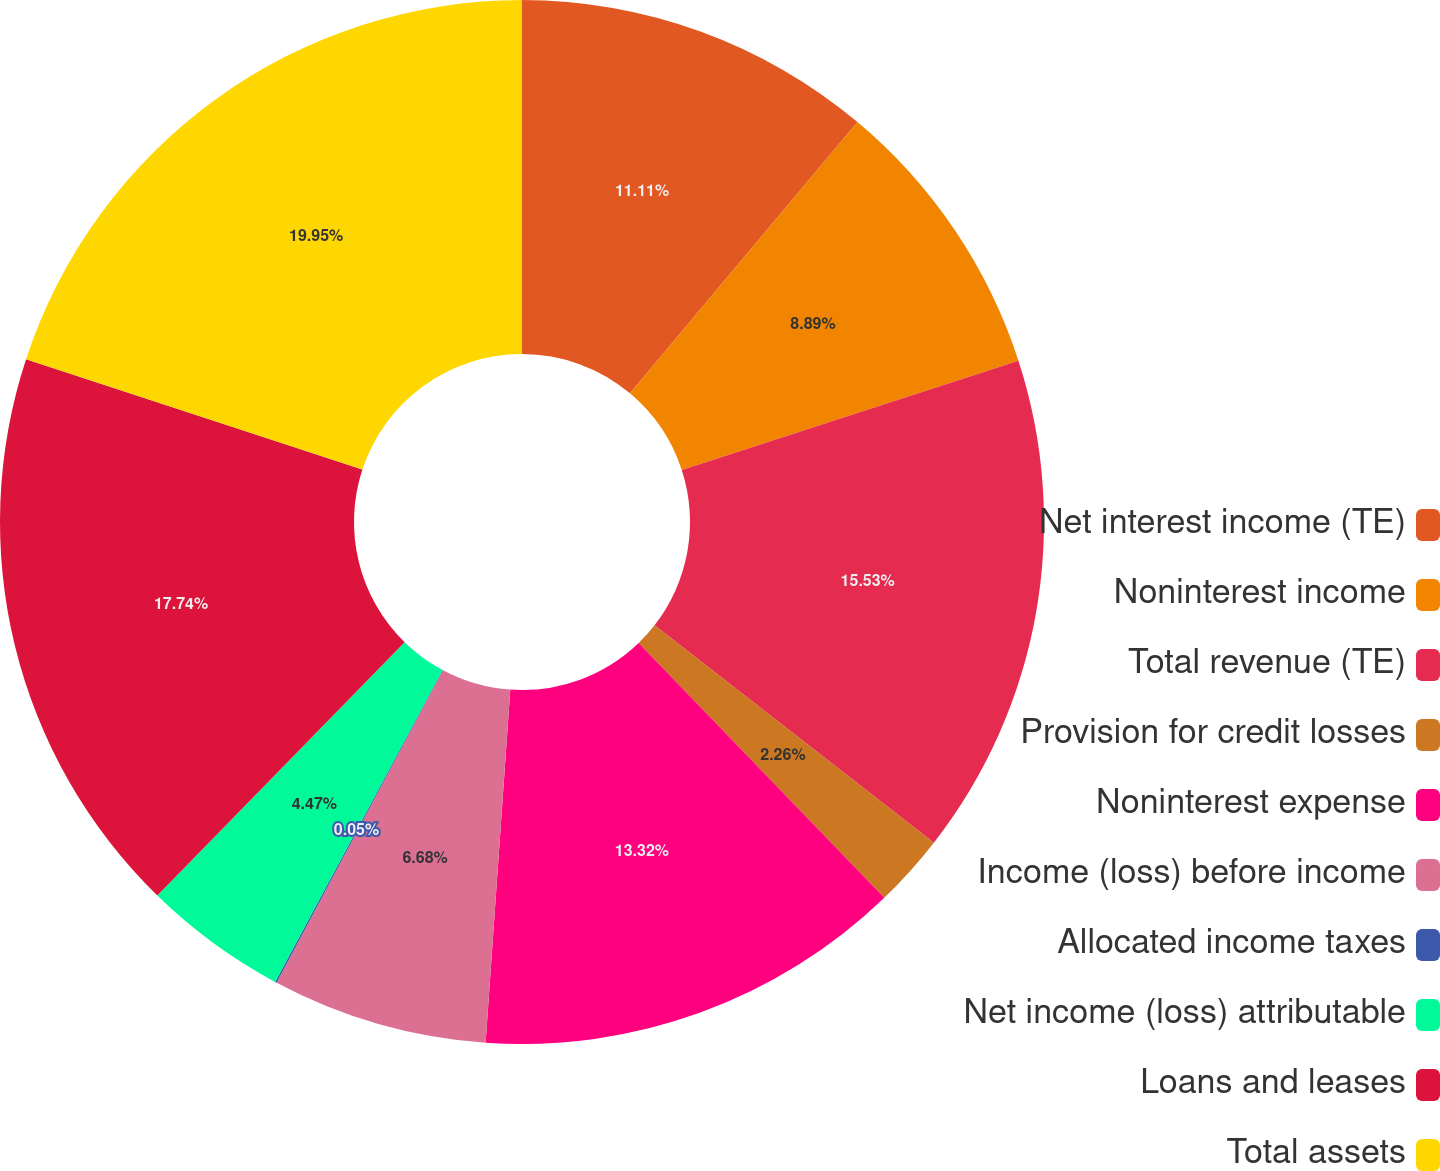Convert chart. <chart><loc_0><loc_0><loc_500><loc_500><pie_chart><fcel>Net interest income (TE)<fcel>Noninterest income<fcel>Total revenue (TE)<fcel>Provision for credit losses<fcel>Noninterest expense<fcel>Income (loss) before income<fcel>Allocated income taxes<fcel>Net income (loss) attributable<fcel>Loans and leases<fcel>Total assets<nl><fcel>11.11%<fcel>8.89%<fcel>15.53%<fcel>2.26%<fcel>13.32%<fcel>6.68%<fcel>0.05%<fcel>4.47%<fcel>17.74%<fcel>19.95%<nl></chart> 